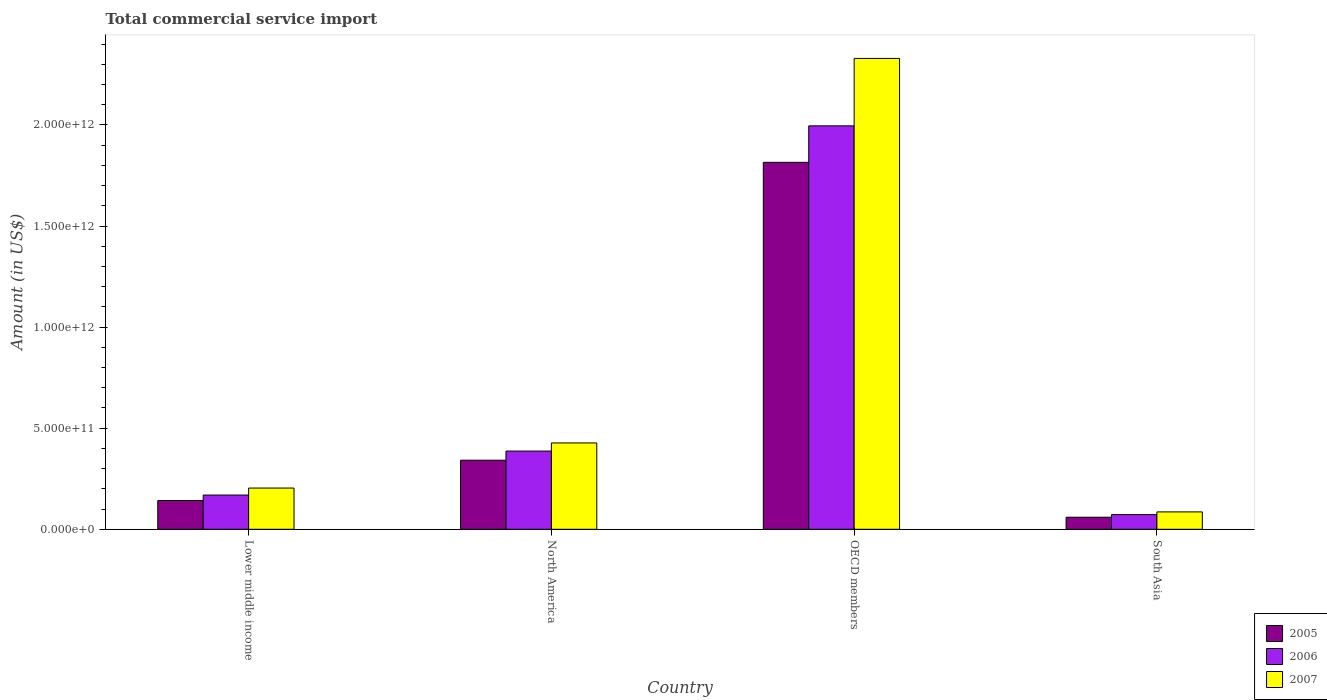How many different coloured bars are there?
Your answer should be compact. 3. How many groups of bars are there?
Your answer should be compact. 4. How many bars are there on the 3rd tick from the left?
Offer a terse response. 3. How many bars are there on the 1st tick from the right?
Keep it short and to the point. 3. What is the total commercial service import in 2007 in OECD members?
Your answer should be compact. 2.33e+12. Across all countries, what is the maximum total commercial service import in 2005?
Provide a short and direct response. 1.81e+12. Across all countries, what is the minimum total commercial service import in 2005?
Your response must be concise. 5.96e+1. In which country was the total commercial service import in 2007 minimum?
Offer a terse response. South Asia. What is the total total commercial service import in 2007 in the graph?
Give a very brief answer. 3.05e+12. What is the difference between the total commercial service import in 2005 in Lower middle income and that in South Asia?
Provide a short and direct response. 8.26e+1. What is the difference between the total commercial service import in 2007 in North America and the total commercial service import in 2005 in Lower middle income?
Provide a short and direct response. 2.85e+11. What is the average total commercial service import in 2006 per country?
Your response must be concise. 6.56e+11. What is the difference between the total commercial service import of/in 2005 and total commercial service import of/in 2007 in OECD members?
Ensure brevity in your answer.  -5.14e+11. In how many countries, is the total commercial service import in 2005 greater than 2200000000000 US$?
Provide a short and direct response. 0. What is the ratio of the total commercial service import in 2006 in Lower middle income to that in OECD members?
Offer a very short reply. 0.08. Is the total commercial service import in 2005 in OECD members less than that in South Asia?
Your answer should be very brief. No. Is the difference between the total commercial service import in 2005 in North America and OECD members greater than the difference between the total commercial service import in 2007 in North America and OECD members?
Your response must be concise. Yes. What is the difference between the highest and the second highest total commercial service import in 2007?
Ensure brevity in your answer.  -2.12e+12. What is the difference between the highest and the lowest total commercial service import in 2006?
Ensure brevity in your answer.  1.92e+12. Is the sum of the total commercial service import in 2005 in North America and OECD members greater than the maximum total commercial service import in 2007 across all countries?
Keep it short and to the point. No. What does the 2nd bar from the left in South Asia represents?
Offer a very short reply. 2006. Is it the case that in every country, the sum of the total commercial service import in 2006 and total commercial service import in 2007 is greater than the total commercial service import in 2005?
Provide a short and direct response. Yes. How many bars are there?
Your response must be concise. 12. Are all the bars in the graph horizontal?
Your response must be concise. No. How many countries are there in the graph?
Provide a short and direct response. 4. What is the difference between two consecutive major ticks on the Y-axis?
Your response must be concise. 5.00e+11. How many legend labels are there?
Make the answer very short. 3. How are the legend labels stacked?
Keep it short and to the point. Vertical. What is the title of the graph?
Offer a terse response. Total commercial service import. Does "1989" appear as one of the legend labels in the graph?
Make the answer very short. No. What is the label or title of the X-axis?
Your answer should be compact. Country. What is the label or title of the Y-axis?
Keep it short and to the point. Amount (in US$). What is the Amount (in US$) in 2005 in Lower middle income?
Your response must be concise. 1.42e+11. What is the Amount (in US$) of 2006 in Lower middle income?
Provide a succinct answer. 1.69e+11. What is the Amount (in US$) in 2007 in Lower middle income?
Your answer should be compact. 2.04e+11. What is the Amount (in US$) of 2005 in North America?
Your answer should be very brief. 3.42e+11. What is the Amount (in US$) of 2006 in North America?
Offer a terse response. 3.87e+11. What is the Amount (in US$) in 2007 in North America?
Provide a succinct answer. 4.27e+11. What is the Amount (in US$) of 2005 in OECD members?
Your answer should be very brief. 1.81e+12. What is the Amount (in US$) of 2006 in OECD members?
Provide a short and direct response. 2.00e+12. What is the Amount (in US$) of 2007 in OECD members?
Give a very brief answer. 2.33e+12. What is the Amount (in US$) in 2005 in South Asia?
Your answer should be compact. 5.96e+1. What is the Amount (in US$) of 2006 in South Asia?
Provide a short and direct response. 7.25e+1. What is the Amount (in US$) of 2007 in South Asia?
Give a very brief answer. 8.60e+1. Across all countries, what is the maximum Amount (in US$) in 2005?
Provide a short and direct response. 1.81e+12. Across all countries, what is the maximum Amount (in US$) in 2006?
Your answer should be compact. 2.00e+12. Across all countries, what is the maximum Amount (in US$) of 2007?
Give a very brief answer. 2.33e+12. Across all countries, what is the minimum Amount (in US$) in 2005?
Give a very brief answer. 5.96e+1. Across all countries, what is the minimum Amount (in US$) of 2006?
Provide a short and direct response. 7.25e+1. Across all countries, what is the minimum Amount (in US$) of 2007?
Offer a terse response. 8.60e+1. What is the total Amount (in US$) in 2005 in the graph?
Ensure brevity in your answer.  2.36e+12. What is the total Amount (in US$) in 2006 in the graph?
Ensure brevity in your answer.  2.62e+12. What is the total Amount (in US$) of 2007 in the graph?
Give a very brief answer. 3.05e+12. What is the difference between the Amount (in US$) of 2005 in Lower middle income and that in North America?
Give a very brief answer. -1.99e+11. What is the difference between the Amount (in US$) in 2006 in Lower middle income and that in North America?
Keep it short and to the point. -2.17e+11. What is the difference between the Amount (in US$) in 2007 in Lower middle income and that in North America?
Provide a short and direct response. -2.23e+11. What is the difference between the Amount (in US$) in 2005 in Lower middle income and that in OECD members?
Make the answer very short. -1.67e+12. What is the difference between the Amount (in US$) of 2006 in Lower middle income and that in OECD members?
Give a very brief answer. -1.83e+12. What is the difference between the Amount (in US$) in 2007 in Lower middle income and that in OECD members?
Keep it short and to the point. -2.12e+12. What is the difference between the Amount (in US$) of 2005 in Lower middle income and that in South Asia?
Give a very brief answer. 8.26e+1. What is the difference between the Amount (in US$) of 2006 in Lower middle income and that in South Asia?
Your response must be concise. 9.68e+1. What is the difference between the Amount (in US$) in 2007 in Lower middle income and that in South Asia?
Your answer should be compact. 1.18e+11. What is the difference between the Amount (in US$) of 2005 in North America and that in OECD members?
Offer a terse response. -1.47e+12. What is the difference between the Amount (in US$) in 2006 in North America and that in OECD members?
Give a very brief answer. -1.61e+12. What is the difference between the Amount (in US$) in 2007 in North America and that in OECD members?
Give a very brief answer. -1.90e+12. What is the difference between the Amount (in US$) of 2005 in North America and that in South Asia?
Give a very brief answer. 2.82e+11. What is the difference between the Amount (in US$) of 2006 in North America and that in South Asia?
Ensure brevity in your answer.  3.14e+11. What is the difference between the Amount (in US$) in 2007 in North America and that in South Asia?
Give a very brief answer. 3.41e+11. What is the difference between the Amount (in US$) in 2005 in OECD members and that in South Asia?
Ensure brevity in your answer.  1.76e+12. What is the difference between the Amount (in US$) in 2006 in OECD members and that in South Asia?
Ensure brevity in your answer.  1.92e+12. What is the difference between the Amount (in US$) in 2007 in OECD members and that in South Asia?
Offer a very short reply. 2.24e+12. What is the difference between the Amount (in US$) of 2005 in Lower middle income and the Amount (in US$) of 2006 in North America?
Give a very brief answer. -2.45e+11. What is the difference between the Amount (in US$) in 2005 in Lower middle income and the Amount (in US$) in 2007 in North America?
Offer a very short reply. -2.85e+11. What is the difference between the Amount (in US$) in 2006 in Lower middle income and the Amount (in US$) in 2007 in North America?
Make the answer very short. -2.58e+11. What is the difference between the Amount (in US$) of 2005 in Lower middle income and the Amount (in US$) of 2006 in OECD members?
Provide a succinct answer. -1.85e+12. What is the difference between the Amount (in US$) of 2005 in Lower middle income and the Amount (in US$) of 2007 in OECD members?
Make the answer very short. -2.19e+12. What is the difference between the Amount (in US$) in 2006 in Lower middle income and the Amount (in US$) in 2007 in OECD members?
Your answer should be compact. -2.16e+12. What is the difference between the Amount (in US$) of 2005 in Lower middle income and the Amount (in US$) of 2006 in South Asia?
Provide a succinct answer. 6.97e+1. What is the difference between the Amount (in US$) of 2005 in Lower middle income and the Amount (in US$) of 2007 in South Asia?
Offer a very short reply. 5.62e+1. What is the difference between the Amount (in US$) of 2006 in Lower middle income and the Amount (in US$) of 2007 in South Asia?
Give a very brief answer. 8.33e+1. What is the difference between the Amount (in US$) in 2005 in North America and the Amount (in US$) in 2006 in OECD members?
Offer a very short reply. -1.65e+12. What is the difference between the Amount (in US$) of 2005 in North America and the Amount (in US$) of 2007 in OECD members?
Ensure brevity in your answer.  -1.99e+12. What is the difference between the Amount (in US$) of 2006 in North America and the Amount (in US$) of 2007 in OECD members?
Keep it short and to the point. -1.94e+12. What is the difference between the Amount (in US$) in 2005 in North America and the Amount (in US$) in 2006 in South Asia?
Offer a terse response. 2.69e+11. What is the difference between the Amount (in US$) of 2005 in North America and the Amount (in US$) of 2007 in South Asia?
Provide a succinct answer. 2.56e+11. What is the difference between the Amount (in US$) of 2006 in North America and the Amount (in US$) of 2007 in South Asia?
Offer a very short reply. 3.01e+11. What is the difference between the Amount (in US$) of 2005 in OECD members and the Amount (in US$) of 2006 in South Asia?
Provide a short and direct response. 1.74e+12. What is the difference between the Amount (in US$) in 2005 in OECD members and the Amount (in US$) in 2007 in South Asia?
Provide a short and direct response. 1.73e+12. What is the difference between the Amount (in US$) in 2006 in OECD members and the Amount (in US$) in 2007 in South Asia?
Offer a very short reply. 1.91e+12. What is the average Amount (in US$) in 2005 per country?
Your answer should be compact. 5.90e+11. What is the average Amount (in US$) of 2006 per country?
Offer a very short reply. 6.56e+11. What is the average Amount (in US$) of 2007 per country?
Provide a succinct answer. 7.62e+11. What is the difference between the Amount (in US$) of 2005 and Amount (in US$) of 2006 in Lower middle income?
Your response must be concise. -2.71e+1. What is the difference between the Amount (in US$) in 2005 and Amount (in US$) in 2007 in Lower middle income?
Your answer should be compact. -6.17e+1. What is the difference between the Amount (in US$) in 2006 and Amount (in US$) in 2007 in Lower middle income?
Give a very brief answer. -3.46e+1. What is the difference between the Amount (in US$) in 2005 and Amount (in US$) in 2006 in North America?
Provide a succinct answer. -4.52e+1. What is the difference between the Amount (in US$) of 2005 and Amount (in US$) of 2007 in North America?
Your answer should be very brief. -8.54e+1. What is the difference between the Amount (in US$) in 2006 and Amount (in US$) in 2007 in North America?
Your answer should be very brief. -4.02e+1. What is the difference between the Amount (in US$) in 2005 and Amount (in US$) in 2006 in OECD members?
Your answer should be compact. -1.80e+11. What is the difference between the Amount (in US$) in 2005 and Amount (in US$) in 2007 in OECD members?
Keep it short and to the point. -5.14e+11. What is the difference between the Amount (in US$) of 2006 and Amount (in US$) of 2007 in OECD members?
Your response must be concise. -3.34e+11. What is the difference between the Amount (in US$) in 2005 and Amount (in US$) in 2006 in South Asia?
Offer a terse response. -1.29e+1. What is the difference between the Amount (in US$) of 2005 and Amount (in US$) of 2007 in South Asia?
Make the answer very short. -2.64e+1. What is the difference between the Amount (in US$) of 2006 and Amount (in US$) of 2007 in South Asia?
Your answer should be compact. -1.35e+1. What is the ratio of the Amount (in US$) of 2005 in Lower middle income to that in North America?
Offer a very short reply. 0.42. What is the ratio of the Amount (in US$) in 2006 in Lower middle income to that in North America?
Give a very brief answer. 0.44. What is the ratio of the Amount (in US$) in 2007 in Lower middle income to that in North America?
Provide a succinct answer. 0.48. What is the ratio of the Amount (in US$) of 2005 in Lower middle income to that in OECD members?
Your answer should be very brief. 0.08. What is the ratio of the Amount (in US$) of 2006 in Lower middle income to that in OECD members?
Offer a very short reply. 0.08. What is the ratio of the Amount (in US$) in 2007 in Lower middle income to that in OECD members?
Your answer should be compact. 0.09. What is the ratio of the Amount (in US$) in 2005 in Lower middle income to that in South Asia?
Ensure brevity in your answer.  2.38. What is the ratio of the Amount (in US$) of 2006 in Lower middle income to that in South Asia?
Make the answer very short. 2.34. What is the ratio of the Amount (in US$) in 2007 in Lower middle income to that in South Asia?
Provide a succinct answer. 2.37. What is the ratio of the Amount (in US$) of 2005 in North America to that in OECD members?
Your response must be concise. 0.19. What is the ratio of the Amount (in US$) of 2006 in North America to that in OECD members?
Offer a very short reply. 0.19. What is the ratio of the Amount (in US$) in 2007 in North America to that in OECD members?
Offer a very short reply. 0.18. What is the ratio of the Amount (in US$) of 2005 in North America to that in South Asia?
Your answer should be compact. 5.73. What is the ratio of the Amount (in US$) of 2006 in North America to that in South Asia?
Provide a short and direct response. 5.33. What is the ratio of the Amount (in US$) in 2007 in North America to that in South Asia?
Your answer should be very brief. 4.97. What is the ratio of the Amount (in US$) in 2005 in OECD members to that in South Asia?
Provide a short and direct response. 30.43. What is the ratio of the Amount (in US$) in 2006 in OECD members to that in South Asia?
Offer a terse response. 27.52. What is the ratio of the Amount (in US$) of 2007 in OECD members to that in South Asia?
Provide a succinct answer. 27.08. What is the difference between the highest and the second highest Amount (in US$) of 2005?
Give a very brief answer. 1.47e+12. What is the difference between the highest and the second highest Amount (in US$) in 2006?
Offer a very short reply. 1.61e+12. What is the difference between the highest and the second highest Amount (in US$) of 2007?
Keep it short and to the point. 1.90e+12. What is the difference between the highest and the lowest Amount (in US$) in 2005?
Provide a succinct answer. 1.76e+12. What is the difference between the highest and the lowest Amount (in US$) of 2006?
Keep it short and to the point. 1.92e+12. What is the difference between the highest and the lowest Amount (in US$) in 2007?
Offer a terse response. 2.24e+12. 